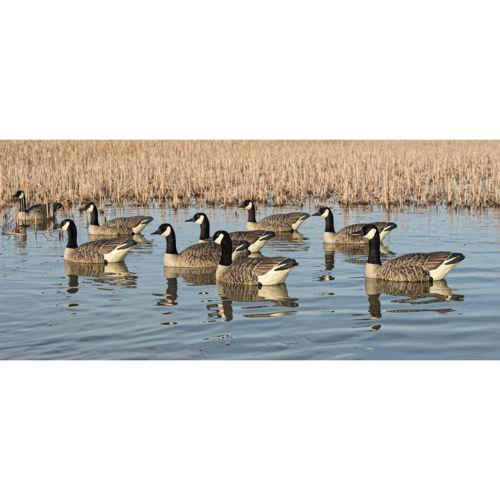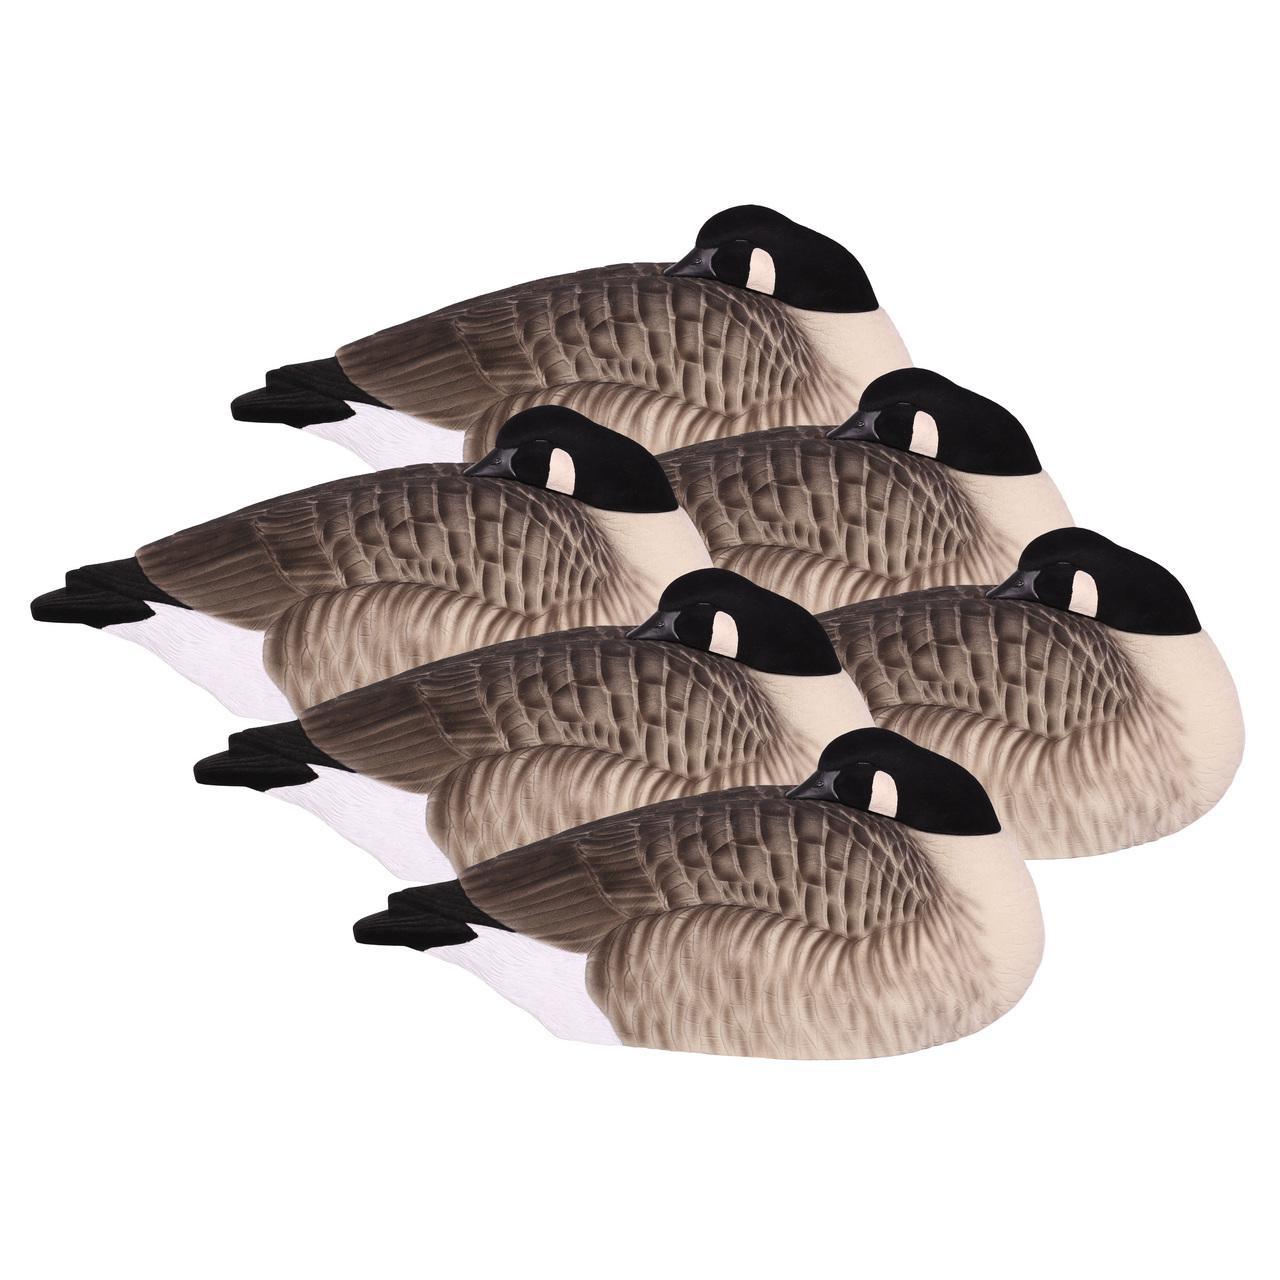The first image is the image on the left, the second image is the image on the right. For the images shown, is this caption "Ducks in the left image are in water." true? Answer yes or no. Yes. The first image is the image on the left, the second image is the image on the right. For the images shown, is this caption "Both images show a flock of canada geese, but in only one of the images are the geese in water." true? Answer yes or no. Yes. 